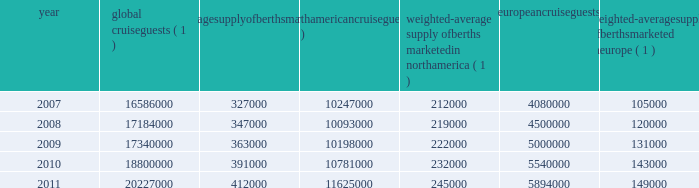Part i berths at the end of 2011 .
There are approximately 10 ships with an estimated 34000 berths that are expected to be placed in service in the north american cruise market between 2012 and 2016 .
Europe in europe , cruising represents a smaller but growing sector of the vacation industry .
It has experienced a compound annual growth rate in cruise guests of approximately 9.6% ( 9.6 % ) from 2007 to 2011 and we believe this market has significant continued growth poten- tial .
We estimate that europe was served by 104 ships with approximately 100000 berths at the beginning of 2007 and by 121 ships with approximately 155000 berths at the end of 2011 .
There are approximately 10 ships with an estimated 28000 berths that are expected to be placed in service in the european cruise market between 2012 and 2016 .
The table details the growth in the global , north american and european cruise markets in terms of cruise guests and estimated weighted-average berths over the past five years : global cruise guests ( 1 ) weighted-average supply of berths marketed globally ( 1 ) north american cruise guests ( 2 ) weighted-average supply of berths marketed in north america ( 1 ) european cruise guests ( 3 ) weighted-average supply of berths marketed in europe ( 1 ) .
( 1 ) source : our estimates of the number of global cruise guests , and the weighted-average supply of berths marketed globally , in north america and europe are based on a combination of data that we obtain from various publicly available cruise industry trade information sources including seatrade insider and cruise line international association .
In addition , our estimates incorporate our own statistical analysis utilizing the same publicly available cruise industry data as a base .
( 2 ) source : cruise line international association based on cruise guests carried for at least two consecutive nights for years 2007 through 2010 .
Year 2011 amounts represent our estimates ( see number 1 above ) .
( 3 ) source : european cruise council for years 2007 through 2010 .
Year 2011 amounts represent our estimates ( see number 1 above ) .
Other markets in addition to expected industry growth in north america and europe as discussed above , we expect the asia/pacific region to demonstrate an even higher growth rate in the near term , although it will continue to represent a relatively small sector compared to north america and europe .
We compete with a number of cruise lines ; however , our principal competitors are carnival corporation & plc , which owns , among others , aida cruises , carnival cruise lines , costa cruises , cunard line , holland america line , iberocruceros , p&o cruises and princess cruises ; disney cruise line ; msc cruises ; norwegian cruise line and oceania cruises .
Cruise lines compete with other vacation alternatives such as land-based resort hotels and sightseeing destinations for consum- ers 2019 leisure time .
Demand for such activities is influ- enced by political and general economic conditions .
Companies within the vacation market are dependent on consumer discretionary spending .
Operating strategies our principal operating strategies are to : and employees and protect the environment in which our vessels and organization operate , to better serve our global guest base and grow our business , order to enhance our revenues while continuing to expand and diversify our guest mix through interna- tional guest sourcing , and ensure adequate cash and liquidity , with the overall goal of maximizing our return on invested capital and long-term shareholder value , our brands throughout the world , revitalization of existing ships and the transfer of key innovations across each brand , while expanding our fleet with the new state-of-the-art cruise ships recently delivered and on order , by deploying them into those markets and itineraries that provide opportunities to optimize returns , while continuing our focus on existing key markets , support ongoing operations and initiatives , and the principal industry distribution channel , while enhancing our consumer outreach programs. .
What was the percent of the anticipated increased in the berths capacity to service european cruise market between 2012 and 2016? 
Computations: (28000 / 155000)
Answer: 0.18065. 